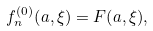<formula> <loc_0><loc_0><loc_500><loc_500>f _ { n } ^ { ( 0 ) } { \left ( a , \xi \right ) } = F { \left ( a , \xi \right ) } ,</formula> 